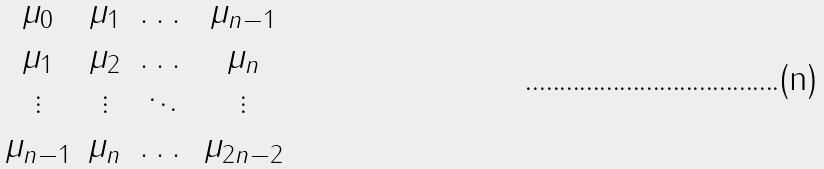Convert formula to latex. <formula><loc_0><loc_0><loc_500><loc_500>\begin{matrix} \mu _ { 0 } & \mu _ { 1 } & \dots & \mu _ { n - 1 } \\ \mu _ { 1 } & \mu _ { 2 } & \dots & \mu _ { n } \\ \vdots & \vdots & \ddots & \vdots \\ \mu _ { n - 1 } & \mu _ { n } & \dots & \mu _ { 2 n - 2 } \end{matrix}</formula> 